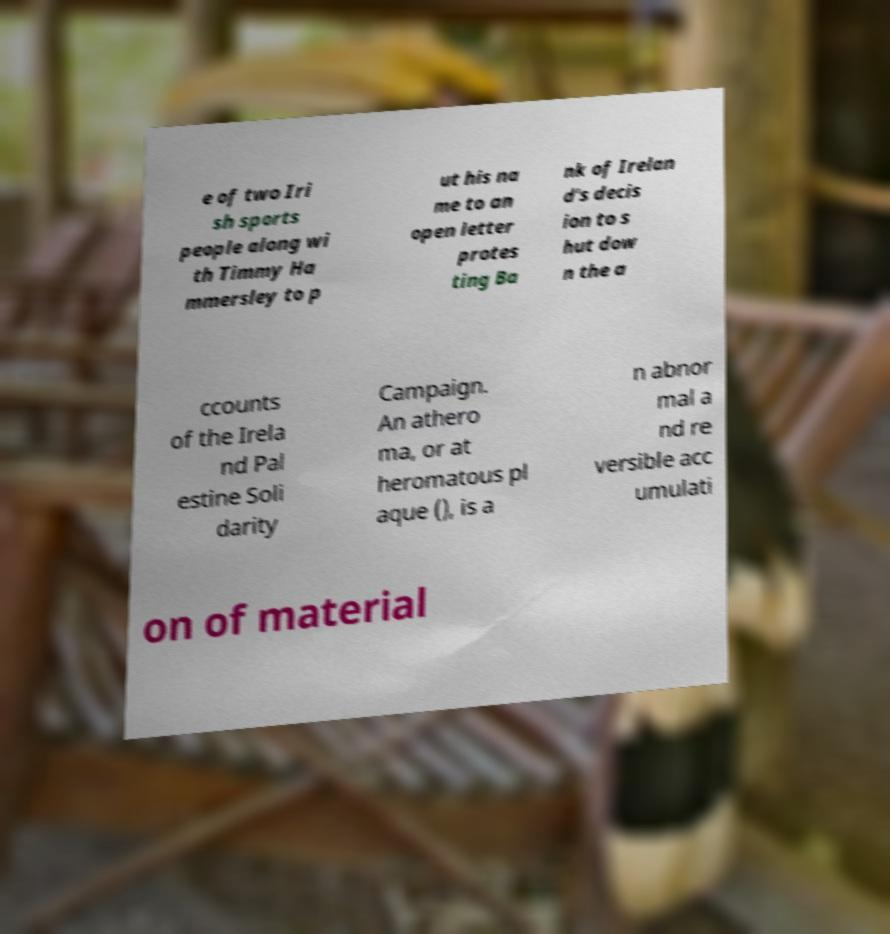Please identify and transcribe the text found in this image. e of two Iri sh sports people along wi th Timmy Ha mmersley to p ut his na me to an open letter protes ting Ba nk of Irelan d's decis ion to s hut dow n the a ccounts of the Irela nd Pal estine Soli darity Campaign. An athero ma, or at heromatous pl aque (), is a n abnor mal a nd re versible acc umulati on of material 